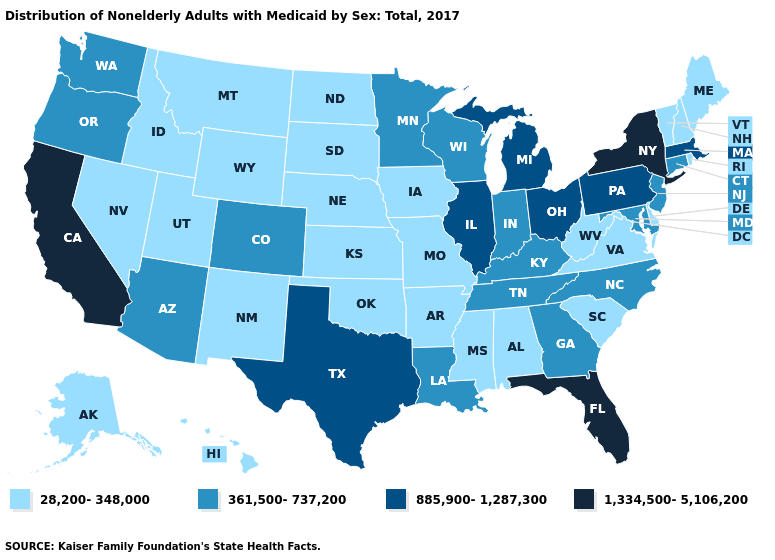What is the value of Michigan?
Keep it brief. 885,900-1,287,300. Name the states that have a value in the range 361,500-737,200?
Give a very brief answer. Arizona, Colorado, Connecticut, Georgia, Indiana, Kentucky, Louisiana, Maryland, Minnesota, New Jersey, North Carolina, Oregon, Tennessee, Washington, Wisconsin. Name the states that have a value in the range 28,200-348,000?
Write a very short answer. Alabama, Alaska, Arkansas, Delaware, Hawaii, Idaho, Iowa, Kansas, Maine, Mississippi, Missouri, Montana, Nebraska, Nevada, New Hampshire, New Mexico, North Dakota, Oklahoma, Rhode Island, South Carolina, South Dakota, Utah, Vermont, Virginia, West Virginia, Wyoming. Does the map have missing data?
Be succinct. No. What is the value of Wyoming?
Give a very brief answer. 28,200-348,000. Does California have the highest value in the West?
Answer briefly. Yes. Name the states that have a value in the range 361,500-737,200?
Concise answer only. Arizona, Colorado, Connecticut, Georgia, Indiana, Kentucky, Louisiana, Maryland, Minnesota, New Jersey, North Carolina, Oregon, Tennessee, Washington, Wisconsin. Among the states that border New Hampshire , which have the highest value?
Write a very short answer. Massachusetts. What is the highest value in states that border West Virginia?
Short answer required. 885,900-1,287,300. What is the highest value in states that border Delaware?
Answer briefly. 885,900-1,287,300. What is the value of Utah?
Answer briefly. 28,200-348,000. Which states have the highest value in the USA?
Quick response, please. California, Florida, New York. What is the highest value in the USA?
Concise answer only. 1,334,500-5,106,200. What is the value of Wyoming?
Write a very short answer. 28,200-348,000. How many symbols are there in the legend?
Keep it brief. 4. 